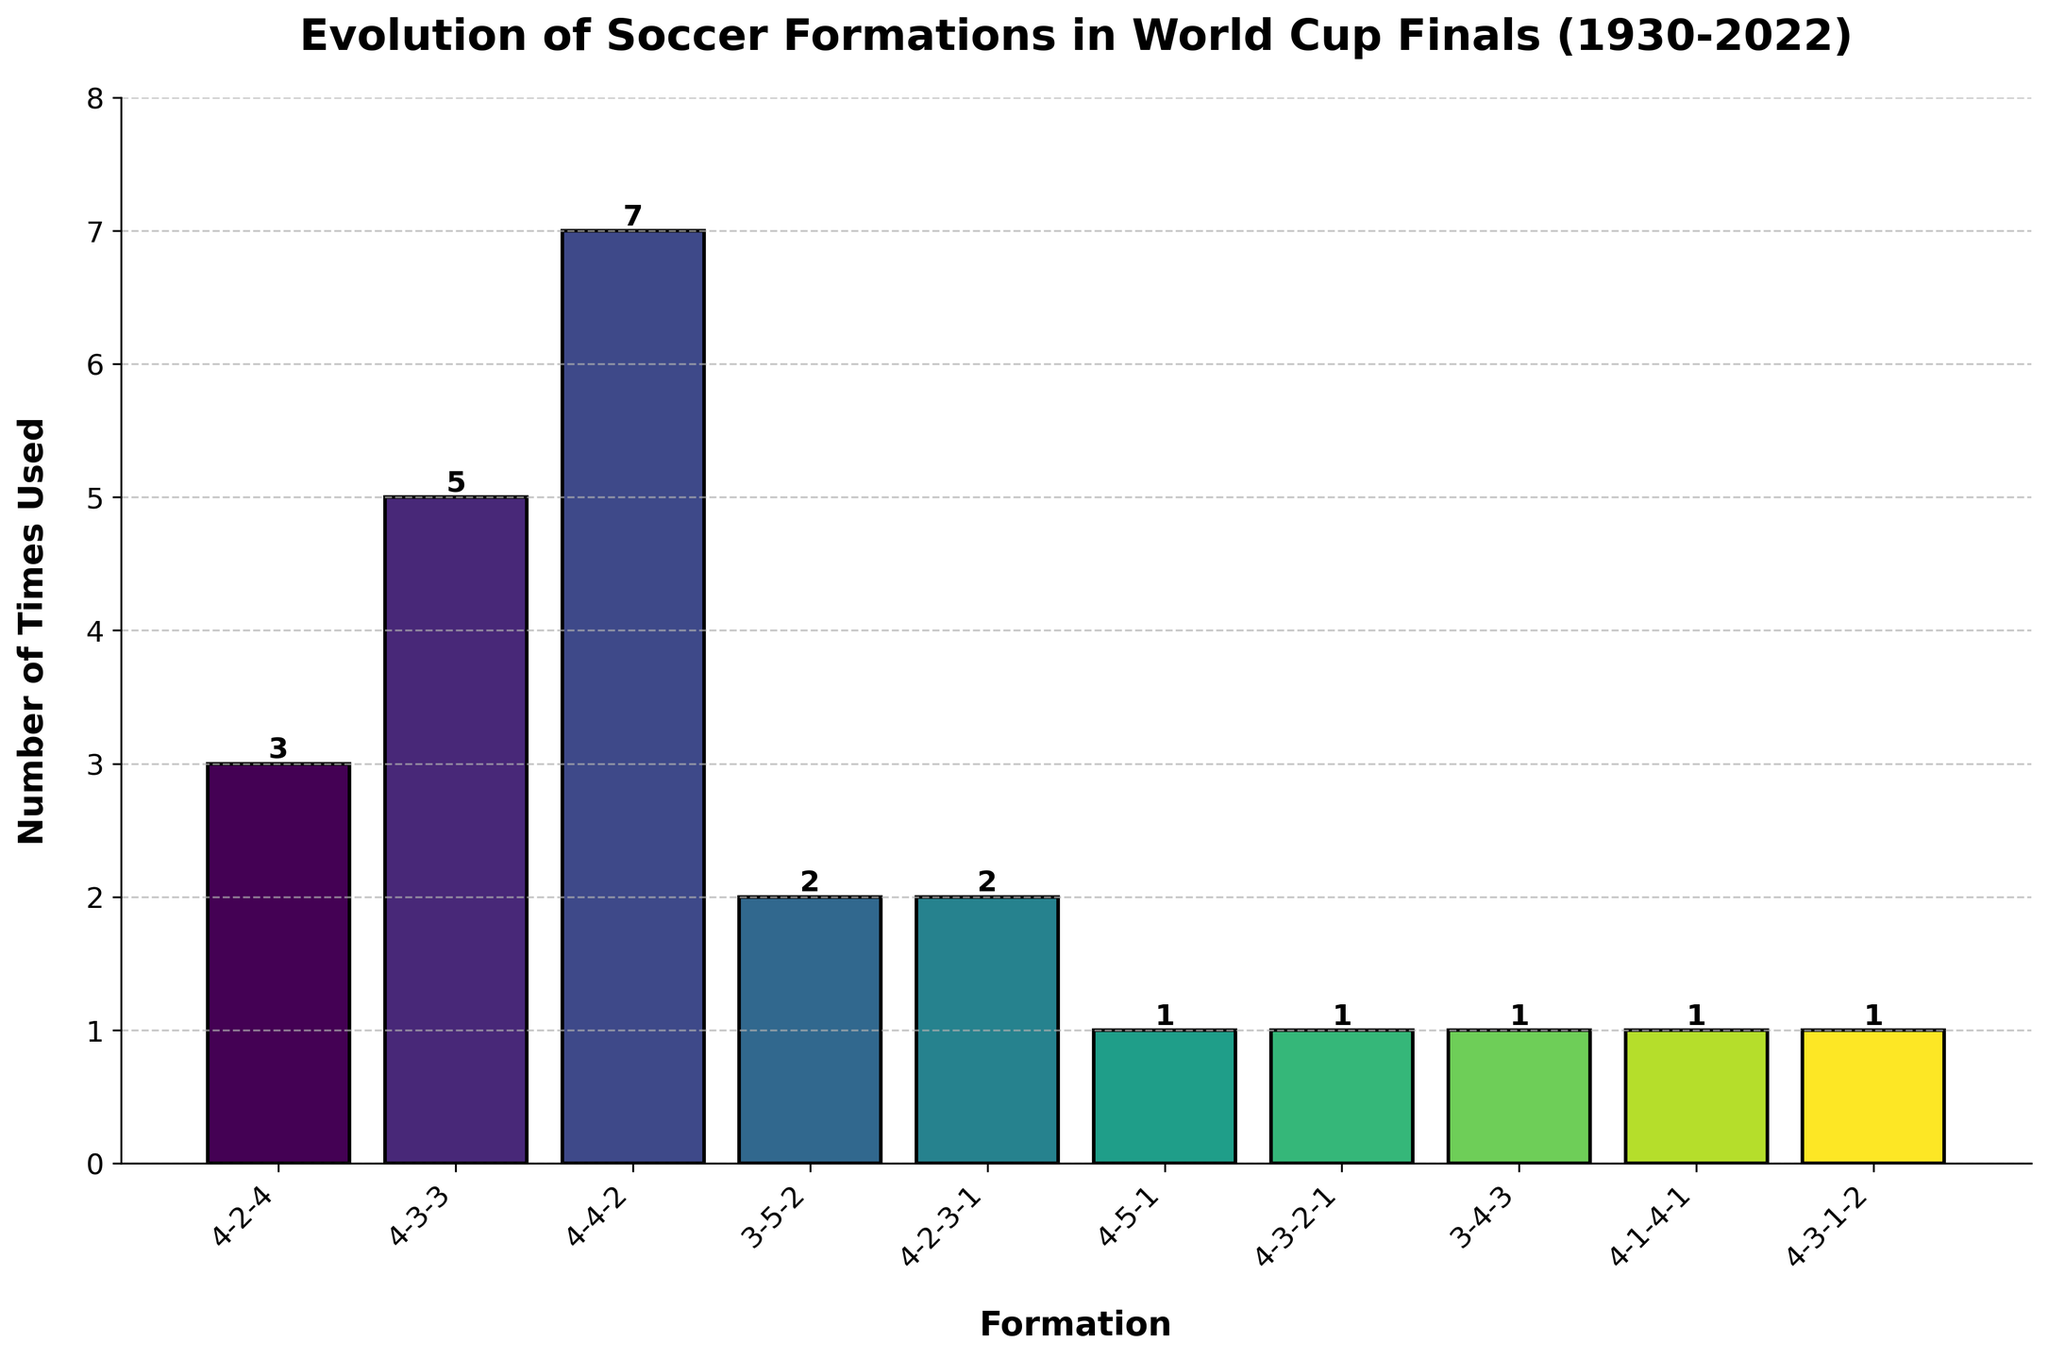What formation was used the most in World Cup finals? The bar chart's highest column corresponds to the formation used most frequently, which is '4-4-2'. Count the possibilities to confirm.
Answer: 4-4-2 Which formations were used only once in World Cup finals? Look for bars with a height of 1. These bars represent formations used only once, which are '4-5-1', '4-3-2-1', '3-4-3', '4-1-4-1', and '4-3-1-2'.
Answer: '4-5-1', '4-3-2-1', '3-4-3', '4-1-4-1', '4-3-1-2' What is the total number of times 4-3-3 and 4-4-2 formations were used? Add the counts for '4-3-3' (5) and '4-4-2' (7).
Answer: 12 How many more times was the 4-4-2 formation used compared to the 4-2-4 formation? The difference between counts of '4-4-2' (7) and '4-2-4' (3) is 7 - 3.
Answer: 4 Which formation has the third highest frequency of usage? Sort the frequencies and find the third largest one. '4-4-2' is highest with 7, '4-3-3' is second with 5, and '4-2-4' is third with 3.
Answer: 4-2-4 Compared to 3-4-3, how many more times was 4-2-3-1 used? '4-2-3-1' has a count of 2 while '3-4-3' has a count of 1. The difference is 2 - 1.
Answer: 1 Which formations have a count of 2? Identify bars with a height of 2. The formations are '3-5-2' and '4-2-3-1'.
Answer: '3-5-2', '4-2-3-1' What is the total count of formations used exactly once or twice in World Cup finals? Sum the counts for formations used once ('4-5-1', '4-3-2-1', '3-4-3', '4-1-4-1', '4-3-1-2' each with 1) and formations used twice (3-5-2 and 4-2-3-1), (1+1+1+1+1+2+2).
Answer: 9 What percentage of the total does the 4-4-2 formation represent? Compute the percentage by (7 / sum of all counts) * 100. The total count is 23, so (7/23)*100 ≈ 30.43%.
Answer: ~30.43% What is the difference in frequencies between the most and least used formations? The most used formation is '4-4-2' with 7 uses, and the least used formations have 1 use each. The difference is 7 - 1.
Answer: 6 